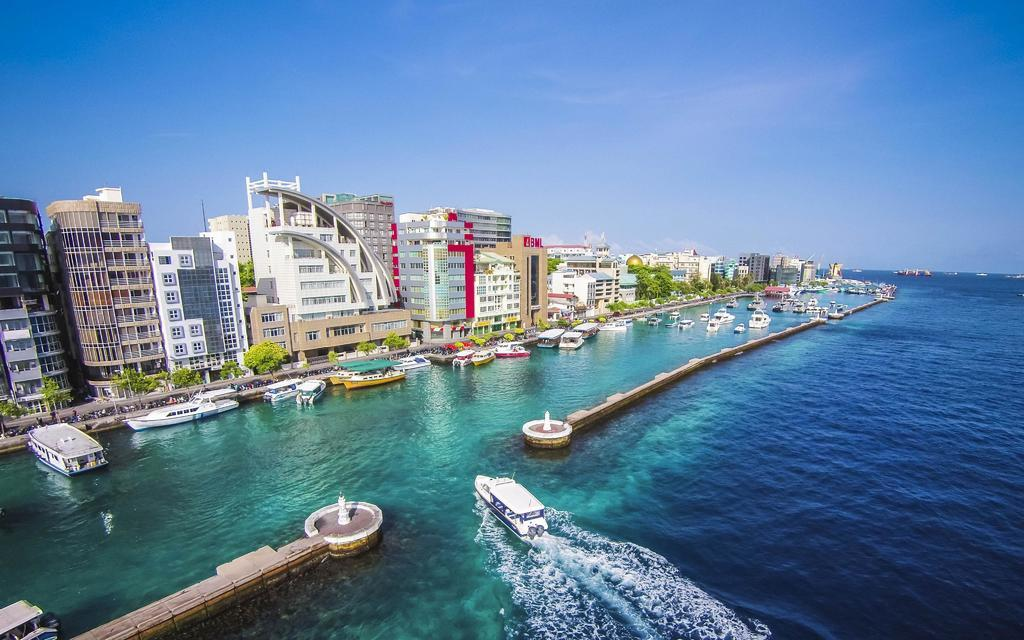What type of structures can be seen in the image? There are many buildings in the image. What else can be seen in the image besides buildings? There are plants and water visible in the image. What is present in the water? There are boats in the water. What is visible at the top of the image? The sky is visible at the top of the image. Where is the quill located in the image? There is no quill present in the image. What type of animals can be seen at the zoo in the image? There is no zoo present in the image. 